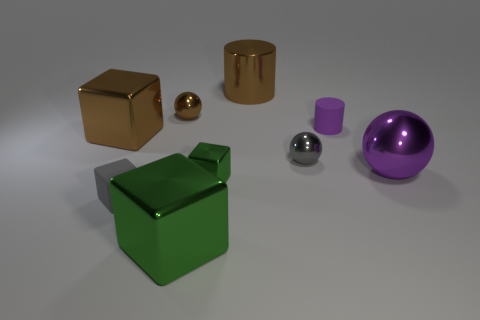Subtract all brown metal cubes. How many cubes are left? 3 Subtract all cyan cylinders. How many green blocks are left? 2 Subtract all blocks. How many objects are left? 5 Subtract 1 blocks. How many blocks are left? 3 Add 6 small rubber cylinders. How many small rubber cylinders are left? 7 Add 6 small brown metallic balls. How many small brown metallic balls exist? 7 Subtract all gray cubes. How many cubes are left? 3 Subtract 0 cyan cubes. How many objects are left? 9 Subtract all green blocks. Subtract all red cylinders. How many blocks are left? 2 Subtract all big purple balls. Subtract all gray shiny things. How many objects are left? 7 